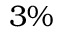<formula> <loc_0><loc_0><loc_500><loc_500>3 \%</formula> 